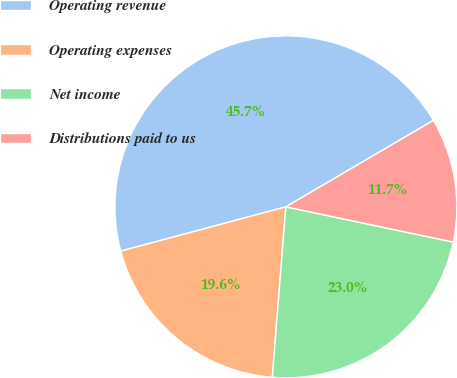Convert chart to OTSL. <chart><loc_0><loc_0><loc_500><loc_500><pie_chart><fcel>Operating revenue<fcel>Operating expenses<fcel>Net income<fcel>Distributions paid to us<nl><fcel>45.73%<fcel>19.56%<fcel>22.96%<fcel>11.74%<nl></chart> 